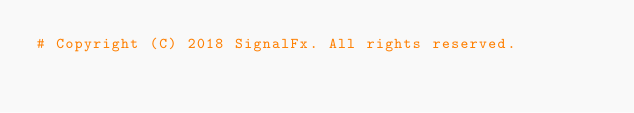<code> <loc_0><loc_0><loc_500><loc_500><_Python_># Copyright (C) 2018 SignalFx. All rights reserved.
</code> 